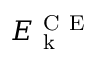Convert formula to latex. <formula><loc_0><loc_0><loc_500><loc_500>E _ { k } ^ { C E }</formula> 